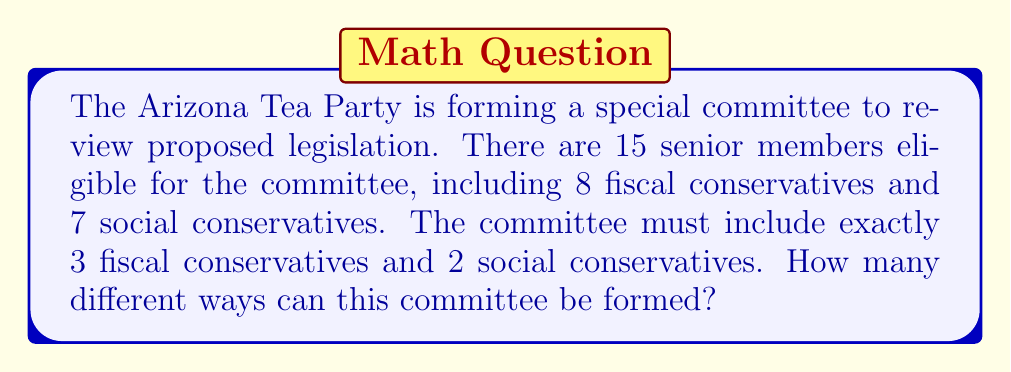Can you solve this math problem? To solve this problem, we can use the multiplication principle from set theory. We need to determine the number of ways to choose fiscal conservatives and social conservatives separately, then multiply these numbers together.

1. Choosing fiscal conservatives:
   We need to select 3 out of 8 fiscal conservatives. This is a combination problem, denoted as $\binom{8}{3}$.
   $$\binom{8}{3} = \frac{8!}{3!(8-3)!} = \frac{8!}{3!5!} = 56$$

2. Choosing social conservatives:
   We need to select 2 out of 7 social conservatives. This is another combination, denoted as $\binom{7}{2}$.
   $$\binom{7}{2} = \frac{7!}{2!(7-2)!} = \frac{7!}{2!5!} = 21$$

3. Applying the multiplication principle:
   The total number of possible committee formations is the product of the number of ways to choose fiscal conservatives and the number of ways to choose social conservatives.

   Total number of committees = $56 \times 21 = 1,176$
Answer: 1,176 possible committee formations 